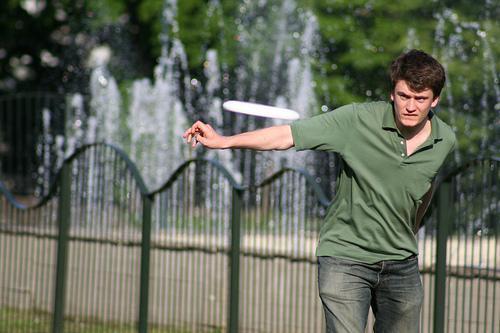How many people are shown?
Give a very brief answer. 1. 